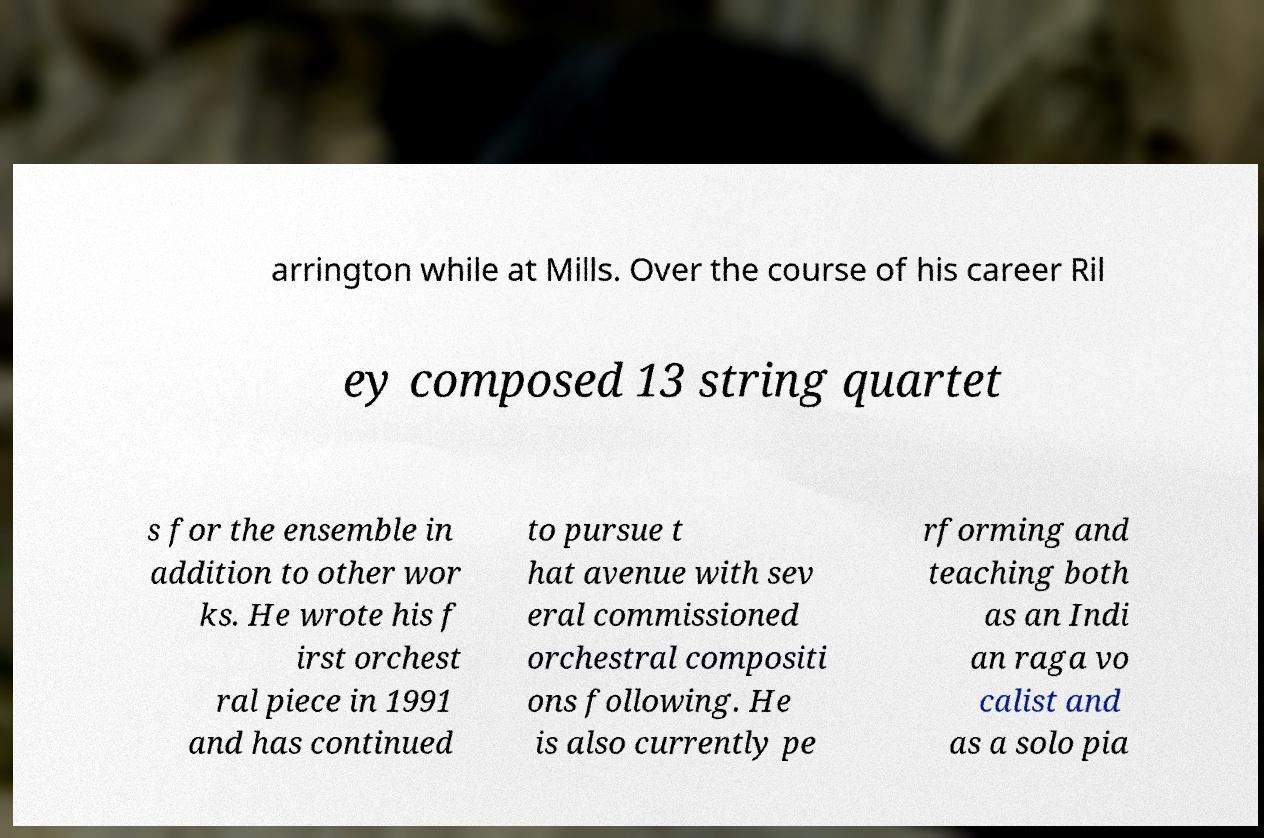I need the written content from this picture converted into text. Can you do that? arrington while at Mills. Over the course of his career Ril ey composed 13 string quartet s for the ensemble in addition to other wor ks. He wrote his f irst orchest ral piece in 1991 and has continued to pursue t hat avenue with sev eral commissioned orchestral compositi ons following. He is also currently pe rforming and teaching both as an Indi an raga vo calist and as a solo pia 